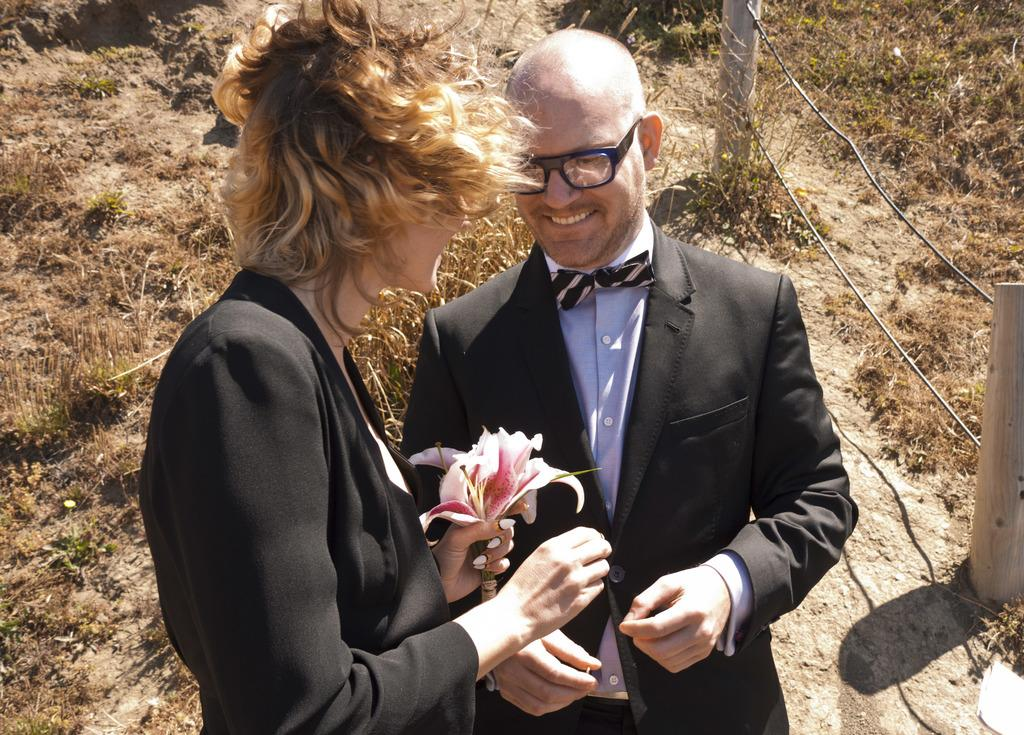How many people are in the image? There are people in the image, but the exact number is not specified. What is a person holding in the image? A person is holding a flower in the image. What type of barrier can be seen in the image? There is a fence in the image. What type of terrain is visible in the image? There is a grassy land in the image. What type of fuel is being used by the people in the image? There is no mention of any fuel or vehicles in the image, so it cannot be determined what type of fuel is being used. 